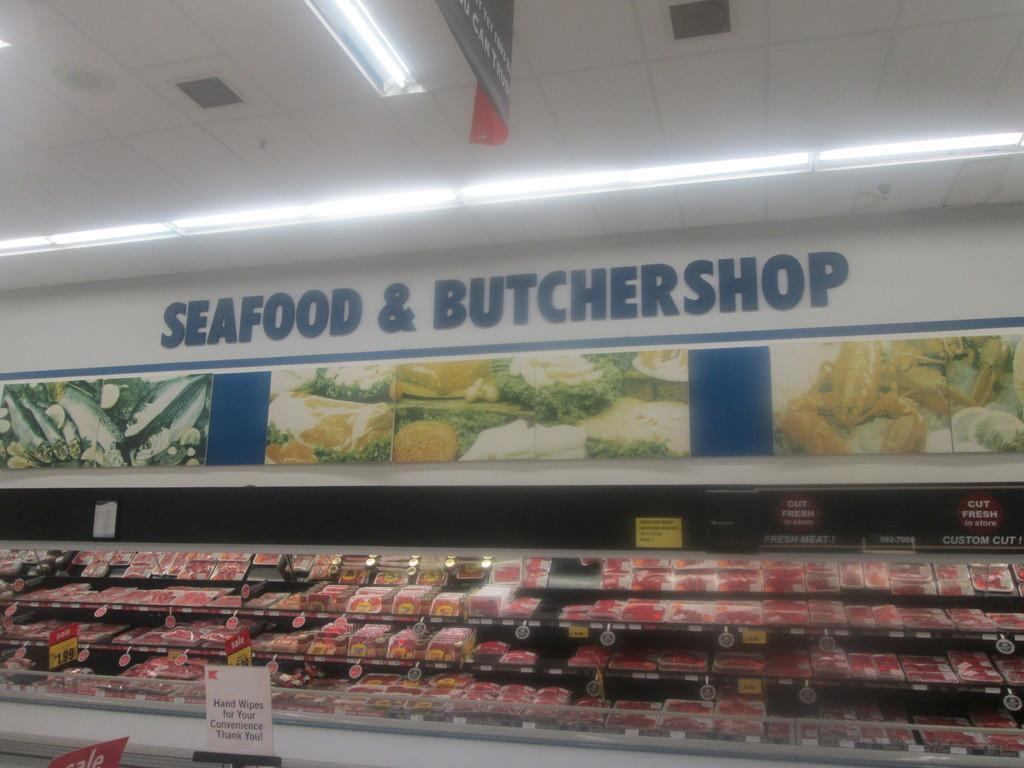<image>
Present a compact description of the photo's key features. The shelves of a seafood butchershop and all of the meat there. 